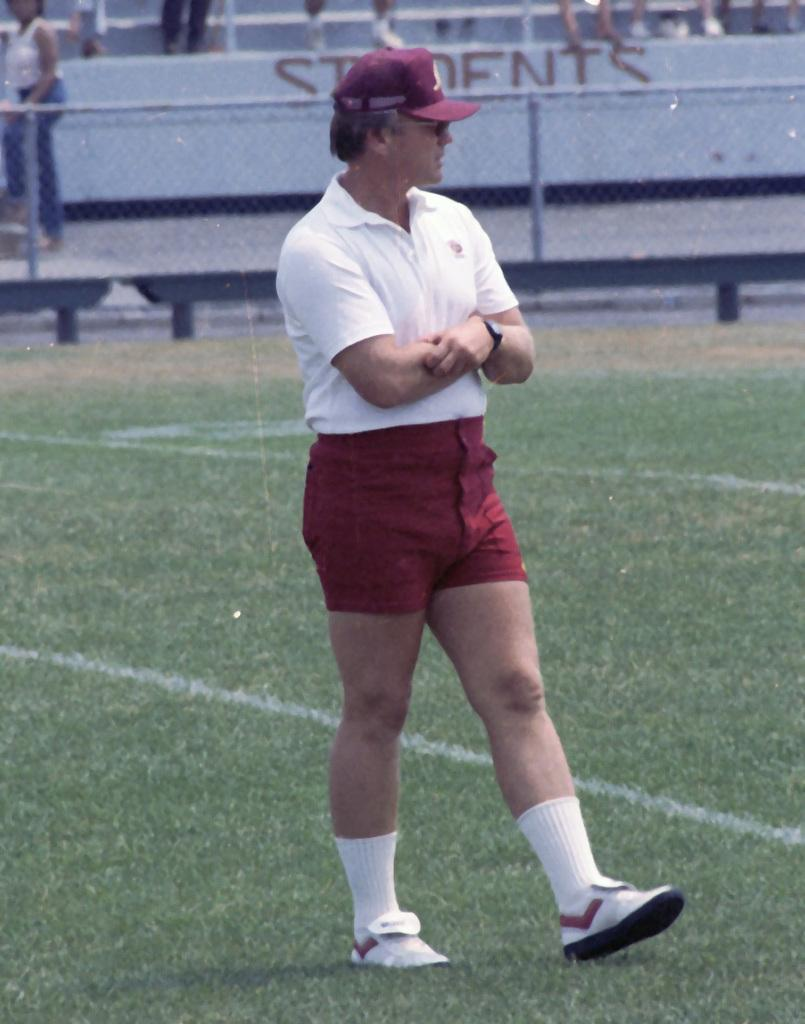What is the man in the image doing? The man in the image is walking. On what surface is the man walking? The man is walking on the ground. What can be seen in the background of the image? There is a fence visible in the image, and there are people behind the fence. How many angles does the man have in the image? The man does not have angles in the image; he is a three-dimensional figure, a person. 